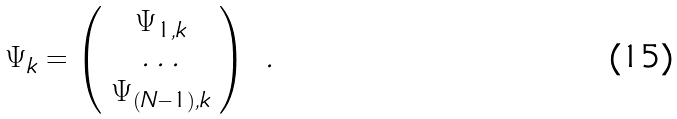<formula> <loc_0><loc_0><loc_500><loc_500>\Psi _ { k } = \left ( \begin{array} { c } \Psi _ { 1 , k } \\ \dots \\ \Psi _ { ( N - 1 ) , k } \end{array} \right ) \ .</formula> 